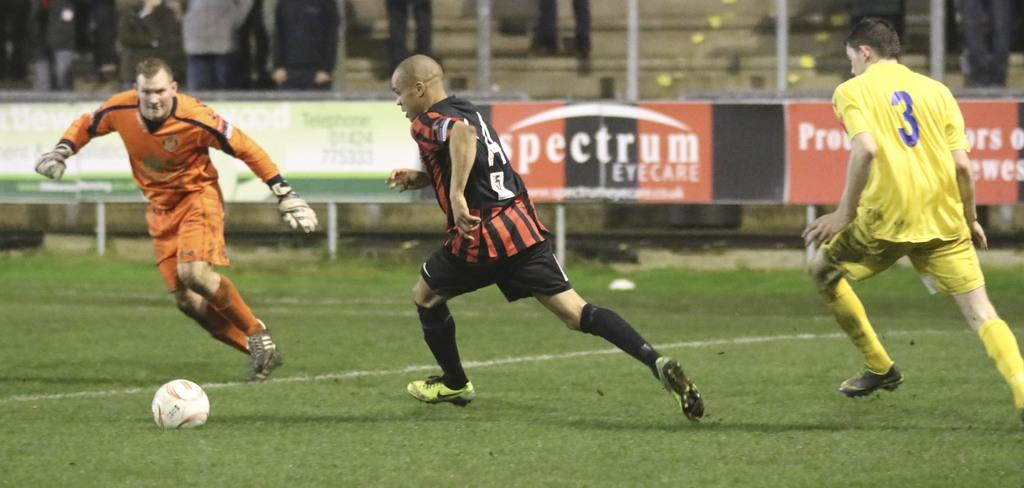<image>
Summarize the visual content of the image. a player that has the number 3 on the back of their yellow jersey 